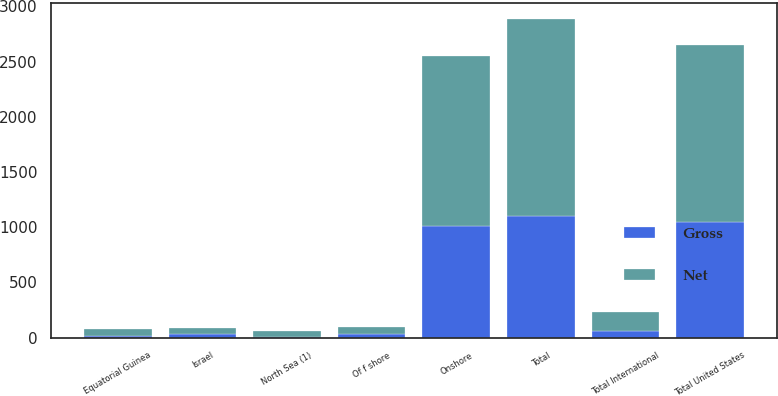Convert chart to OTSL. <chart><loc_0><loc_0><loc_500><loc_500><stacked_bar_chart><ecel><fcel>Onshore<fcel>Of f shore<fcel>Total United States<fcel>Equatorial Guinea<fcel>Israel<fcel>North Sea (1)<fcel>Total International<fcel>Total<nl><fcel>Net<fcel>1535<fcel>65<fcel>1600<fcel>56<fcel>62<fcel>52<fcel>177<fcel>1777<nl><fcel>Gross<fcel>1012<fcel>35<fcel>1047<fcel>19<fcel>29<fcel>7<fcel>59<fcel>1106<nl></chart> 